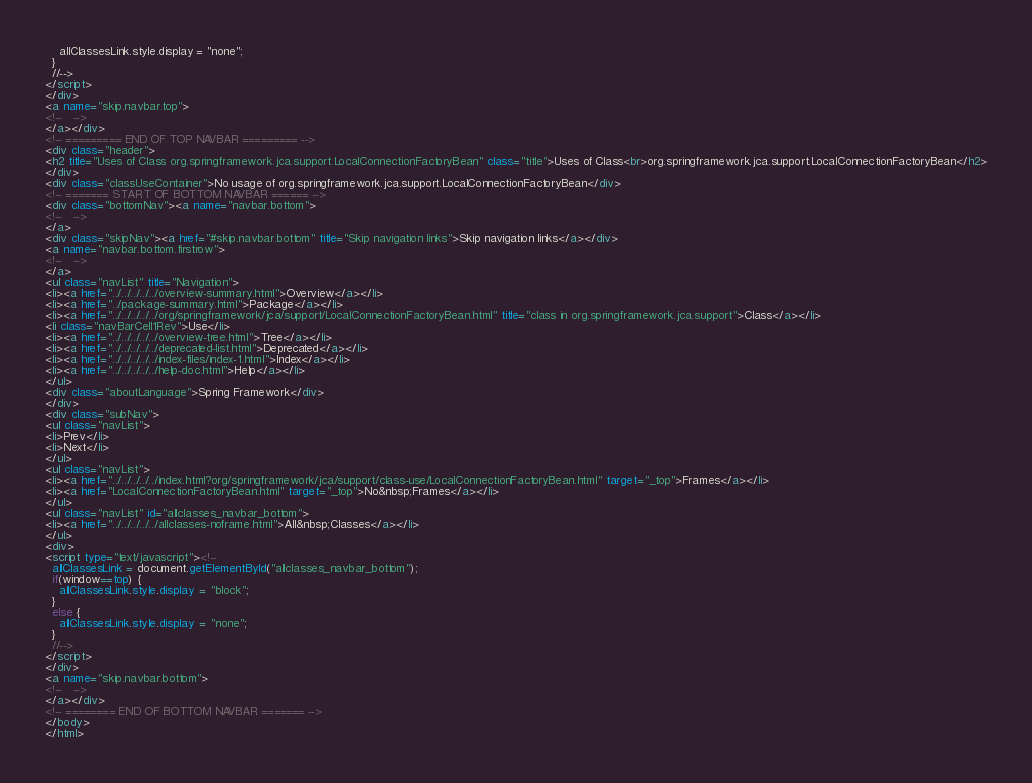<code> <loc_0><loc_0><loc_500><loc_500><_HTML_>    allClassesLink.style.display = "none";
  }
  //-->
</script>
</div>
<a name="skip.navbar.top">
<!--   -->
</a></div>
<!-- ========= END OF TOP NAVBAR ========= -->
<div class="header">
<h2 title="Uses of Class org.springframework.jca.support.LocalConnectionFactoryBean" class="title">Uses of Class<br>org.springframework.jca.support.LocalConnectionFactoryBean</h2>
</div>
<div class="classUseContainer">No usage of org.springframework.jca.support.LocalConnectionFactoryBean</div>
<!-- ======= START OF BOTTOM NAVBAR ====== -->
<div class="bottomNav"><a name="navbar.bottom">
<!--   -->
</a>
<div class="skipNav"><a href="#skip.navbar.bottom" title="Skip navigation links">Skip navigation links</a></div>
<a name="navbar.bottom.firstrow">
<!--   -->
</a>
<ul class="navList" title="Navigation">
<li><a href="../../../../../overview-summary.html">Overview</a></li>
<li><a href="../package-summary.html">Package</a></li>
<li><a href="../../../../../org/springframework/jca/support/LocalConnectionFactoryBean.html" title="class in org.springframework.jca.support">Class</a></li>
<li class="navBarCell1Rev">Use</li>
<li><a href="../../../../../overview-tree.html">Tree</a></li>
<li><a href="../../../../../deprecated-list.html">Deprecated</a></li>
<li><a href="../../../../../index-files/index-1.html">Index</a></li>
<li><a href="../../../../../help-doc.html">Help</a></li>
</ul>
<div class="aboutLanguage">Spring Framework</div>
</div>
<div class="subNav">
<ul class="navList">
<li>Prev</li>
<li>Next</li>
</ul>
<ul class="navList">
<li><a href="../../../../../index.html?org/springframework/jca/support/class-use/LocalConnectionFactoryBean.html" target="_top">Frames</a></li>
<li><a href="LocalConnectionFactoryBean.html" target="_top">No&nbsp;Frames</a></li>
</ul>
<ul class="navList" id="allclasses_navbar_bottom">
<li><a href="../../../../../allclasses-noframe.html">All&nbsp;Classes</a></li>
</ul>
<div>
<script type="text/javascript"><!--
  allClassesLink = document.getElementById("allclasses_navbar_bottom");
  if(window==top) {
    allClassesLink.style.display = "block";
  }
  else {
    allClassesLink.style.display = "none";
  }
  //-->
</script>
</div>
<a name="skip.navbar.bottom">
<!--   -->
</a></div>
<!-- ======== END OF BOTTOM NAVBAR ======= -->
</body>
</html>
</code> 